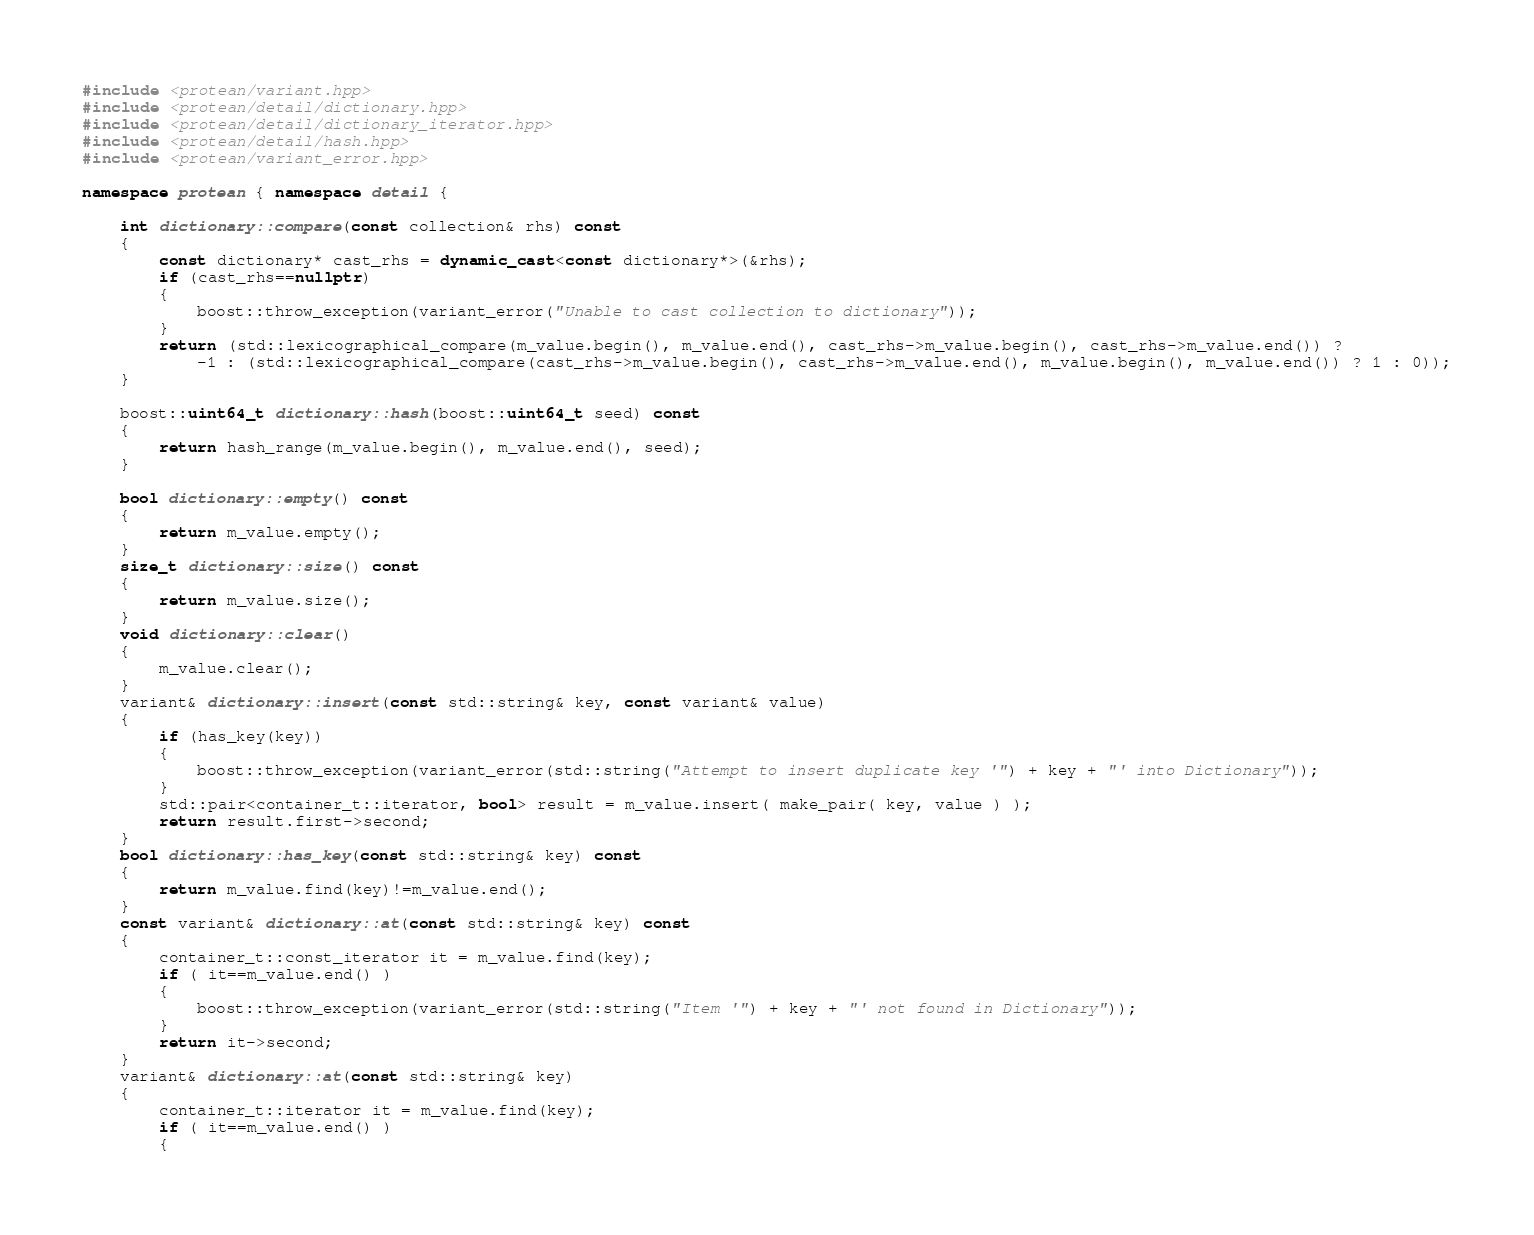Convert code to text. <code><loc_0><loc_0><loc_500><loc_500><_C++_>#include <protean/variant.hpp>
#include <protean/detail/dictionary.hpp>
#include <protean/detail/dictionary_iterator.hpp>
#include <protean/detail/hash.hpp>
#include <protean/variant_error.hpp>

namespace protean { namespace detail {

    int dictionary::compare(const collection& rhs) const
    {
        const dictionary* cast_rhs = dynamic_cast<const dictionary*>(&rhs);
        if (cast_rhs==nullptr)
        {
            boost::throw_exception(variant_error("Unable to cast collection to dictionary"));
        }
        return (std::lexicographical_compare(m_value.begin(), m_value.end(), cast_rhs->m_value.begin(), cast_rhs->m_value.end()) ?
            -1 : (std::lexicographical_compare(cast_rhs->m_value.begin(), cast_rhs->m_value.end(), m_value.begin(), m_value.end()) ? 1 : 0));
    }

    boost::uint64_t dictionary::hash(boost::uint64_t seed) const
    {
        return hash_range(m_value.begin(), m_value.end(), seed);
    }

    bool dictionary::empty() const
    {
        return m_value.empty();
    }
    size_t dictionary::size() const
    {
        return m_value.size();
    }
    void dictionary::clear()
    {
        m_value.clear();
    }
    variant& dictionary::insert(const std::string& key, const variant& value)
    {
        if (has_key(key))
        {
            boost::throw_exception(variant_error(std::string("Attempt to insert duplicate key '") + key + "' into Dictionary"));
        }
        std::pair<container_t::iterator, bool> result = m_value.insert( make_pair( key, value ) );
        return result.first->second;
    }
    bool dictionary::has_key(const std::string& key) const
    {
        return m_value.find(key)!=m_value.end();
    }
    const variant& dictionary::at(const std::string& key) const
    {
        container_t::const_iterator it = m_value.find(key);
        if ( it==m_value.end() )
        {
            boost::throw_exception(variant_error(std::string("Item '") + key + "' not found in Dictionary"));
        }
        return it->second;
    }
    variant& dictionary::at(const std::string& key)
    {
        container_t::iterator it = m_value.find(key);
        if ( it==m_value.end() )
        {</code> 